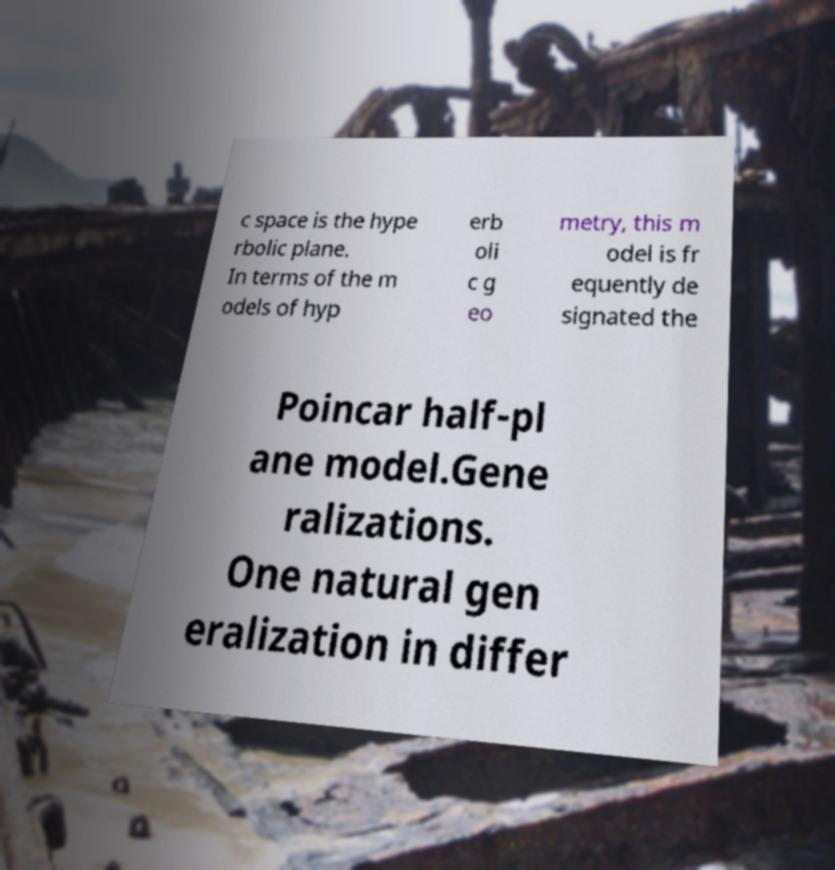Could you extract and type out the text from this image? c space is the hype rbolic plane. In terms of the m odels of hyp erb oli c g eo metry, this m odel is fr equently de signated the Poincar half-pl ane model.Gene ralizations. One natural gen eralization in differ 